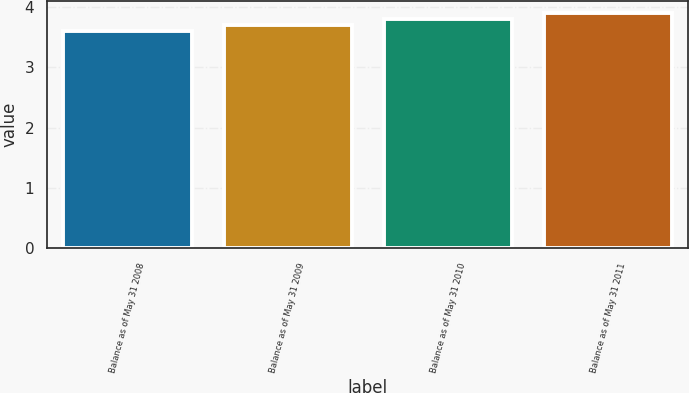<chart> <loc_0><loc_0><loc_500><loc_500><bar_chart><fcel>Balance as of May 31 2008<fcel>Balance as of May 31 2009<fcel>Balance as of May 31 2010<fcel>Balance as of May 31 2011<nl><fcel>3.6<fcel>3.7<fcel>3.8<fcel>3.9<nl></chart> 